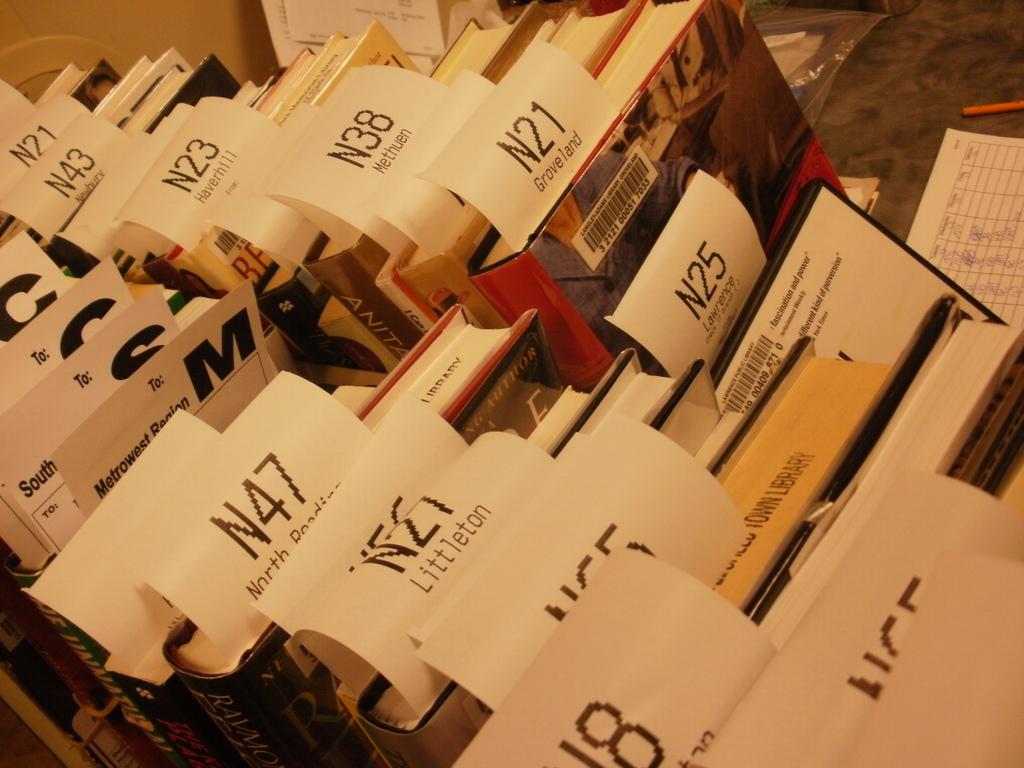Are the books from the town library?
Your response must be concise. Yes. 